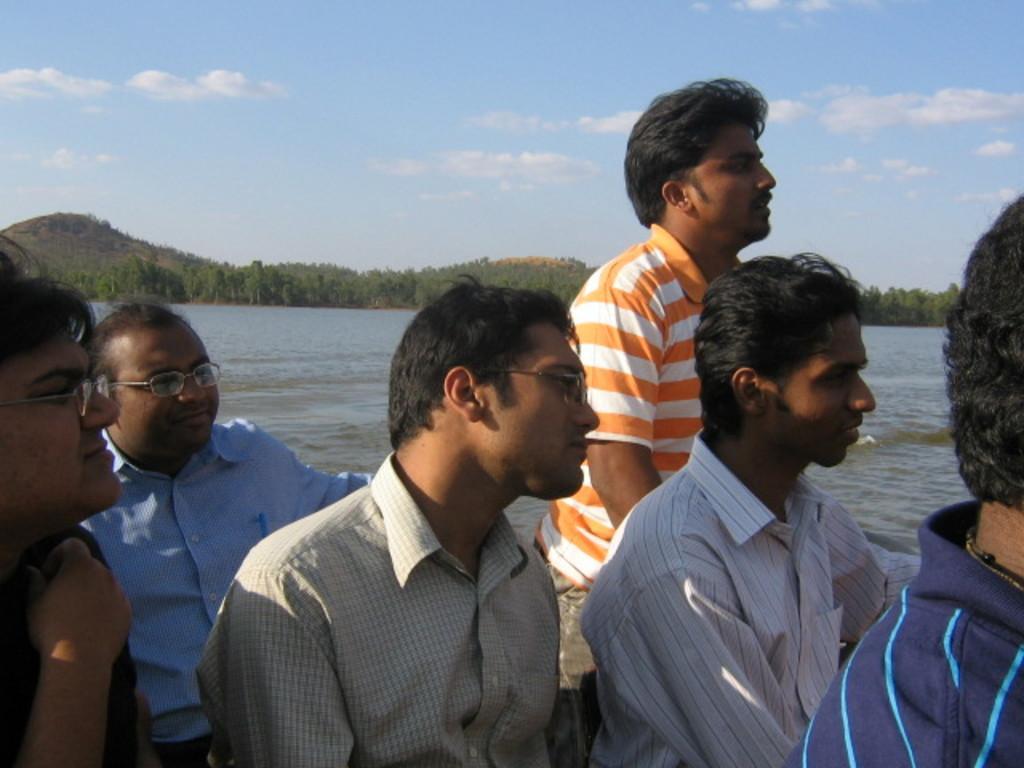How would you summarize this image in a sentence or two? In this image there are a few people sitting and looking to the right side of the image and in the background there are trees, mountains and the sky. 